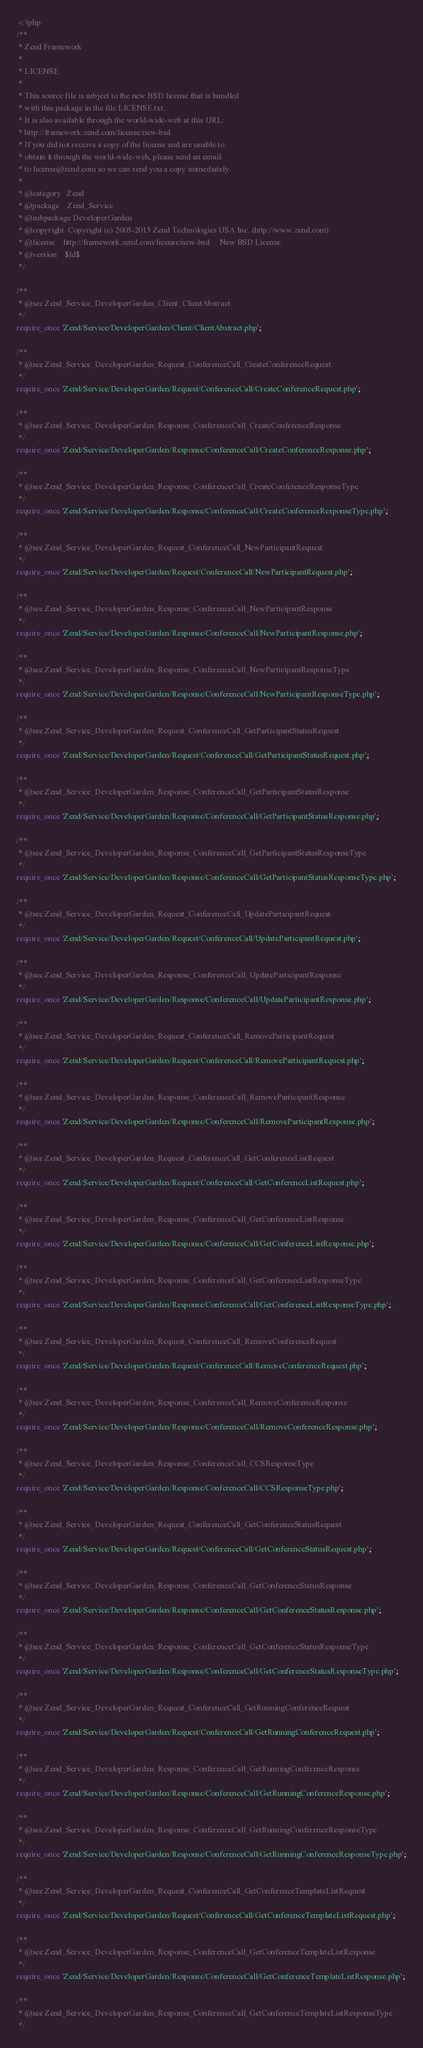Convert code to text. <code><loc_0><loc_0><loc_500><loc_500><_PHP_><?php
/**
 * Zend Framework
 *
 * LICENSE
 *
 * This source file is subject to the new BSD license that is bundled
 * with this package in the file LICENSE.txt.
 * It is also available through the world-wide-web at this URL:
 * http://framework.zend.com/license/new-bsd
 * If you did not receive a copy of the license and are unable to
 * obtain it through the world-wide-web, please send an email
 * to license@zend.com so we can send you a copy immediately.
 *
 * @category   Zend
 * @package    Zend_Service
 * @subpackage DeveloperGarden
 * @copyright  Copyright (c) 2005-2015 Zend Technologies USA Inc. (http://www.zend.com)
 * @license    http://framework.zend.com/license/new-bsd     New BSD License
 * @version    $Id$
 */

/**
 * @see Zend_Service_DeveloperGarden_Client_ClientAbstract
 */
require_once 'Zend/Service/DeveloperGarden/Client/ClientAbstract.php';

/**
 * @see Zend_Service_DeveloperGarden_Request_ConferenceCall_CreateConferenceRequest
 */
require_once 'Zend/Service/DeveloperGarden/Request/ConferenceCall/CreateConferenceRequest.php';

/**
 * @see Zend_Service_DeveloperGarden_Response_ConferenceCall_CreateConferenceResponse
 */
require_once 'Zend/Service/DeveloperGarden/Response/ConferenceCall/CreateConferenceResponse.php';

/**
 * @see Zend_Service_DeveloperGarden_Response_ConferenceCall_CreateConferenceResponseType
 */
require_once 'Zend/Service/DeveloperGarden/Response/ConferenceCall/CreateConferenceResponseType.php';

/**
 * @see Zend_Service_DeveloperGarden_Request_ConferenceCall_NewParticipantRequest
 */
require_once 'Zend/Service/DeveloperGarden/Request/ConferenceCall/NewParticipantRequest.php';

/**
 * @see Zend_Service_DeveloperGarden_Response_ConferenceCall_NewParticipantResponse
 */
require_once 'Zend/Service/DeveloperGarden/Response/ConferenceCall/NewParticipantResponse.php';

/**
 * @see Zend_Service_DeveloperGarden_Response_ConferenceCall_NewParticipantResponseType
 */
require_once 'Zend/Service/DeveloperGarden/Response/ConferenceCall/NewParticipantResponseType.php';

/**
 * @see Zend_Service_DeveloperGarden_Request_ConferenceCall_GetParticipantStatusRequest
 */
require_once 'Zend/Service/DeveloperGarden/Request/ConferenceCall/GetParticipantStatusRequest.php';

/**
 * @see Zend_Service_DeveloperGarden_Response_ConferenceCall_GetParticipantStatusResponse
 */
require_once 'Zend/Service/DeveloperGarden/Response/ConferenceCall/GetParticipantStatusResponse.php';

/**
 * @see Zend_Service_DeveloperGarden_Response_ConferenceCall_GetParticipantStatusResponseType
 */
require_once 'Zend/Service/DeveloperGarden/Response/ConferenceCall/GetParticipantStatusResponseType.php';

/**
 * @see Zend_Service_DeveloperGarden_Request_ConferenceCall_UpdateParticipantRequest
 */
require_once 'Zend/Service/DeveloperGarden/Request/ConferenceCall/UpdateParticipantRequest.php';

/**
 * @see Zend_Service_DeveloperGarden_Response_ConferenceCall_UpdateParticipantResponse
 */
require_once 'Zend/Service/DeveloperGarden/Response/ConferenceCall/UpdateParticipantResponse.php';

/**
 * @see Zend_Service_DeveloperGarden_Request_ConferenceCall_RemoveParticipantRequest
 */
require_once 'Zend/Service/DeveloperGarden/Request/ConferenceCall/RemoveParticipantRequest.php';

/**
 * @see Zend_Service_DeveloperGarden_Response_ConferenceCall_RemoveParticipantResponse
 */
require_once 'Zend/Service/DeveloperGarden/Response/ConferenceCall/RemoveParticipantResponse.php';

/**
 * @see Zend_Service_DeveloperGarden_Request_ConferenceCall_GetConferenceListRequest
 */
require_once 'Zend/Service/DeveloperGarden/Request/ConferenceCall/GetConferenceListRequest.php';

/**
 * @see Zend_Service_DeveloperGarden_Response_ConferenceCall_GetConferenceListResponse
 */
require_once 'Zend/Service/DeveloperGarden/Response/ConferenceCall/GetConferenceListResponse.php';

/**
 * @see Zend_Service_DeveloperGarden_Response_ConferenceCall_GetConferenceListResponseType
 */
require_once 'Zend/Service/DeveloperGarden/Response/ConferenceCall/GetConferenceListResponseType.php';

/**
 * @see Zend_Service_DeveloperGarden_Request_ConferenceCall_RemoveConferenceRequest
 */
require_once 'Zend/Service/DeveloperGarden/Request/ConferenceCall/RemoveConferenceRequest.php';

/**
 * @see Zend_Service_DeveloperGarden_Response_ConferenceCall_RemoveConferenceResponse
 */
require_once 'Zend/Service/DeveloperGarden/Response/ConferenceCall/RemoveConferenceResponse.php';

/**
 * @see Zend_Service_DeveloperGarden_Response_ConferenceCall_CCSResponseType
 */
require_once 'Zend/Service/DeveloperGarden/Response/ConferenceCall/CCSResponseType.php';

/**
 * @see Zend_Service_DeveloperGarden_Request_ConferenceCall_GetConferenceStatusRequest
 */
require_once 'Zend/Service/DeveloperGarden/Request/ConferenceCall/GetConferenceStatusRequest.php';

/**
 * @see Zend_Service_DeveloperGarden_Response_ConferenceCall_GetConferenceStatusResponse
 */
require_once 'Zend/Service/DeveloperGarden/Response/ConferenceCall/GetConferenceStatusResponse.php';

/**
 * @see Zend_Service_DeveloperGarden_Response_ConferenceCall_GetConferenceStatusResponseType
 */
require_once 'Zend/Service/DeveloperGarden/Response/ConferenceCall/GetConferenceStatusResponseType.php';

/**
 * @see Zend_Service_DeveloperGarden_Request_ConferenceCall_GetRunningConferenceRequest
 */
require_once 'Zend/Service/DeveloperGarden/Request/ConferenceCall/GetRunningConferenceRequest.php';

/**
 * @see Zend_Service_DeveloperGarden_Response_ConferenceCall_GetRunningConferenceResponse
 */
require_once 'Zend/Service/DeveloperGarden/Response/ConferenceCall/GetRunningConferenceResponse.php';

/**
 * @see Zend_Service_DeveloperGarden_Response_ConferenceCall_GetRunningConferenceResponseType
 */
require_once 'Zend/Service/DeveloperGarden/Response/ConferenceCall/GetRunningConferenceResponseType.php';

/**
 * @see Zend_Service_DeveloperGarden_Request_ConferenceCall_GetConferenceTemplateListRequest
 */
require_once 'Zend/Service/DeveloperGarden/Request/ConferenceCall/GetConferenceTemplateListRequest.php';

/**
 * @see Zend_Service_DeveloperGarden_Response_ConferenceCall_GetConferenceTemplateListResponse
 */
require_once 'Zend/Service/DeveloperGarden/Response/ConferenceCall/GetConferenceTemplateListResponse.php';

/**
 * @see Zend_Service_DeveloperGarden_Response_ConferenceCall_GetConferenceTemplateListResponseType
 */</code> 